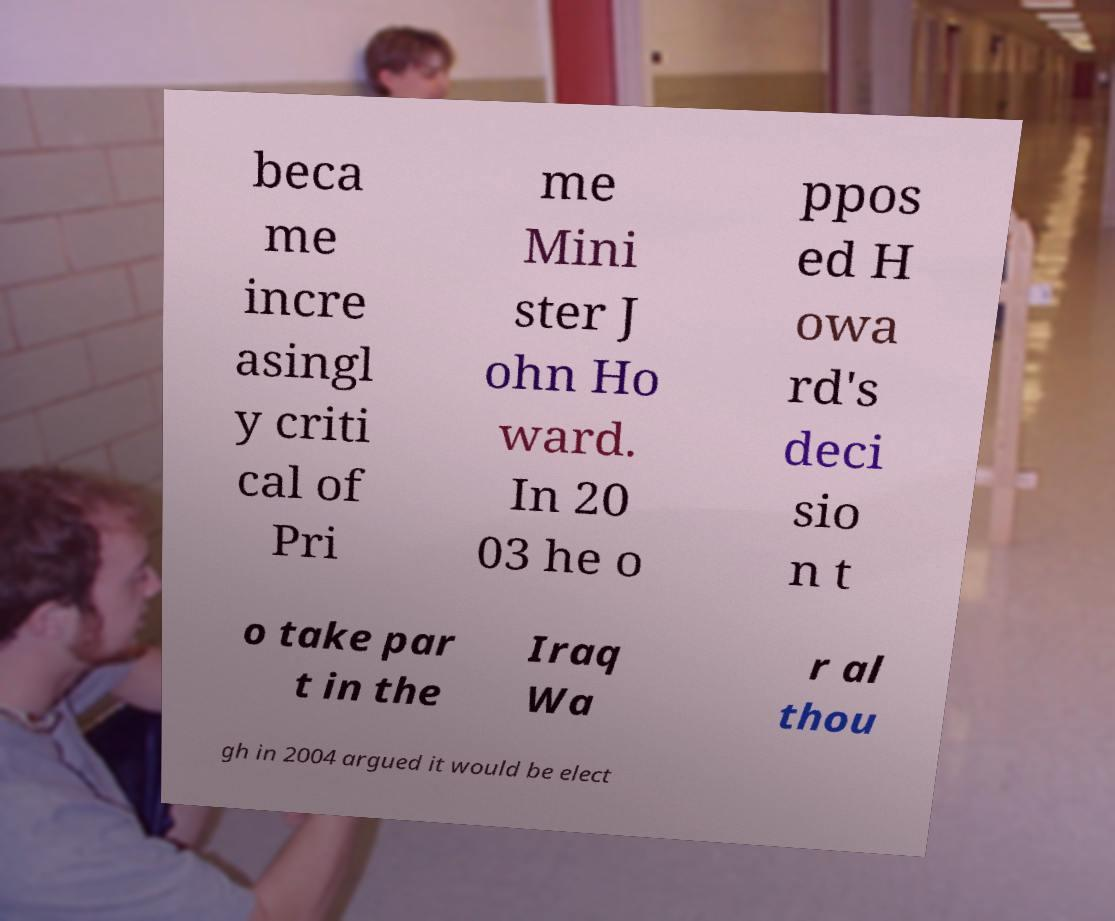Please read and relay the text visible in this image. What does it say? beca me incre asingl y criti cal of Pri me Mini ster J ohn Ho ward. In 20 03 he o ppos ed H owa rd's deci sio n t o take par t in the Iraq Wa r al thou gh in 2004 argued it would be elect 